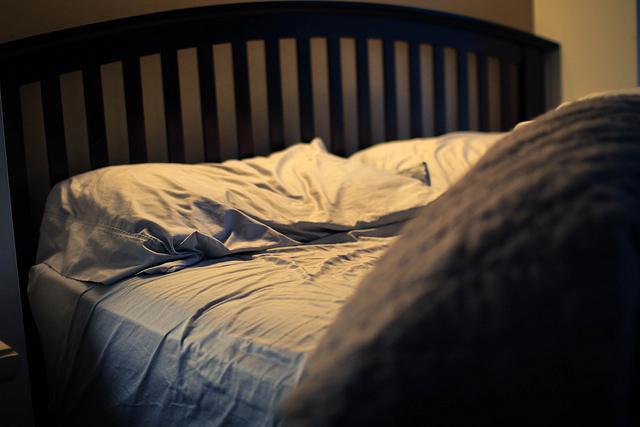How many pillows are visible in this image?
Give a very brief answer. 2. 